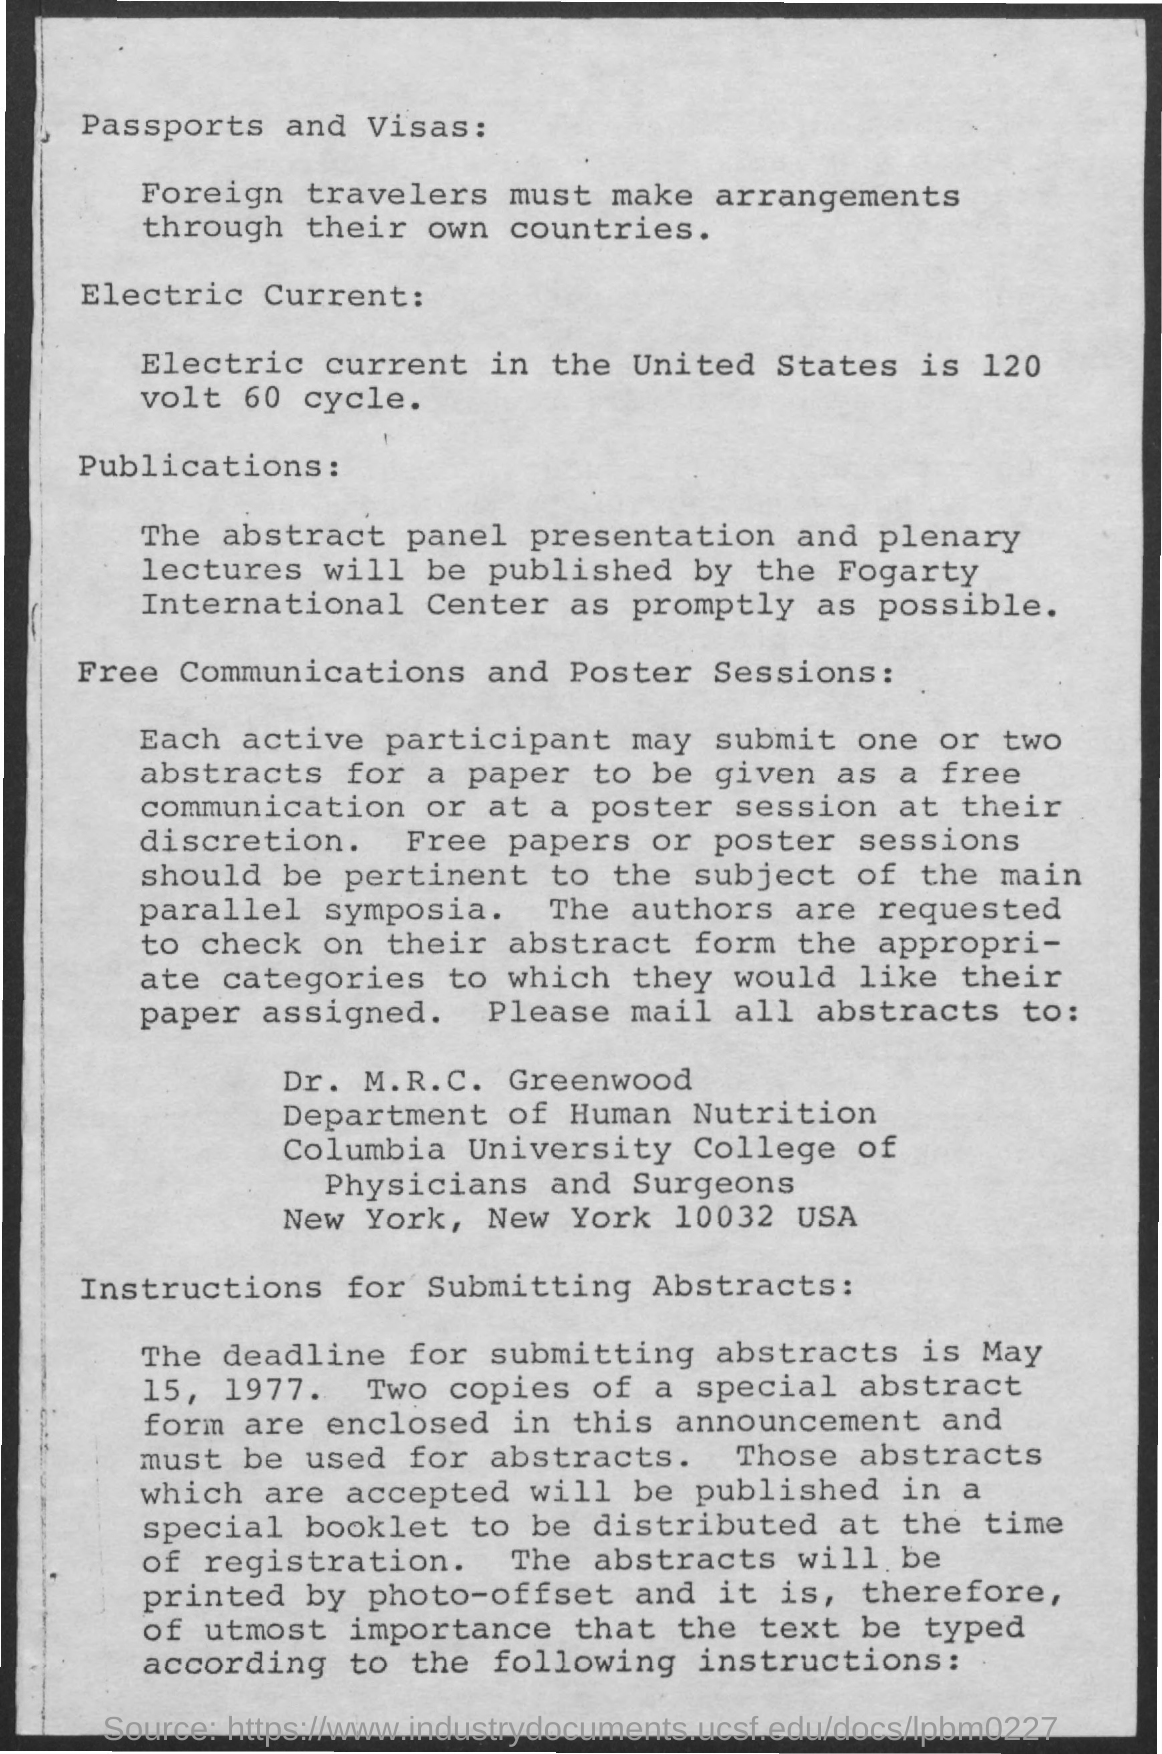What is the electric current in the United States?
Offer a very short reply. 120 volt 60 cycle. Who will publish the abstract panel presentation and plenary lectures?
Provide a short and direct response. The fogarty international center. To whom should all abstracts be mailed?
Your answer should be very brief. Dr. M. R. C. Greenwood. What is the deadline for submitting abstracts?
Provide a succinct answer. May 15, 1977. 